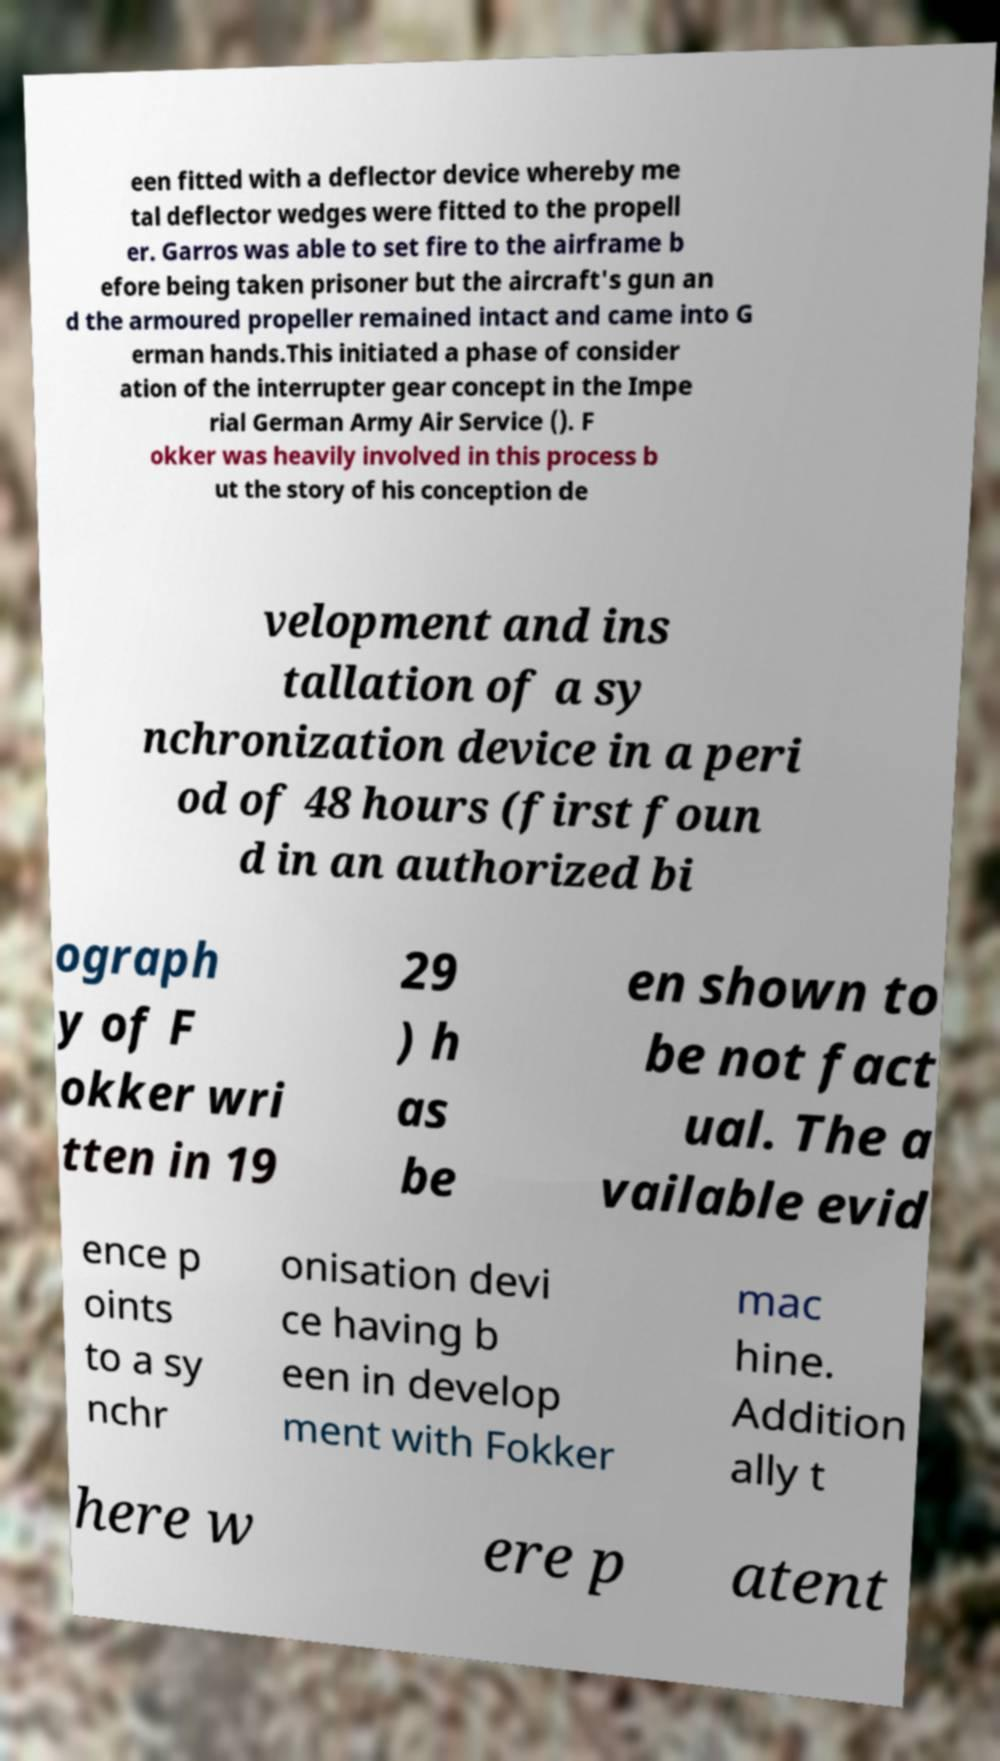Please read and relay the text visible in this image. What does it say? een fitted with a deflector device whereby me tal deflector wedges were fitted to the propell er. Garros was able to set fire to the airframe b efore being taken prisoner but the aircraft's gun an d the armoured propeller remained intact and came into G erman hands.This initiated a phase of consider ation of the interrupter gear concept in the Impe rial German Army Air Service (). F okker was heavily involved in this process b ut the story of his conception de velopment and ins tallation of a sy nchronization device in a peri od of 48 hours (first foun d in an authorized bi ograph y of F okker wri tten in 19 29 ) h as be en shown to be not fact ual. The a vailable evid ence p oints to a sy nchr onisation devi ce having b een in develop ment with Fokker mac hine. Addition ally t here w ere p atent 